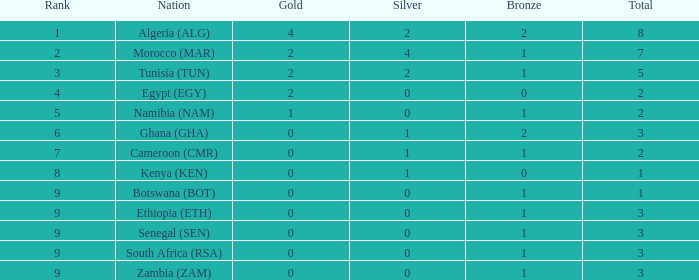What is the minimum bronze for a nation of egypt (egy) with less than 2 golds? None. 